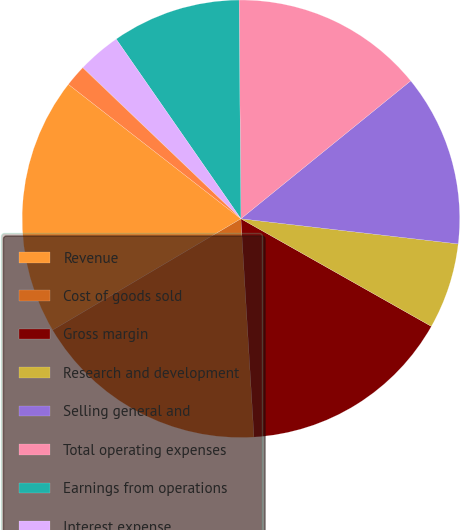Convert chart to OTSL. <chart><loc_0><loc_0><loc_500><loc_500><pie_chart><fcel>Revenue<fcel>Cost of goods sold<fcel>Gross margin<fcel>Research and development<fcel>Selling general and<fcel>Total operating expenses<fcel>Earnings from operations<fcel>Interest expense<fcel>Interest income<fcel>Other (income) expense net<nl><fcel>19.03%<fcel>17.45%<fcel>15.86%<fcel>6.35%<fcel>12.69%<fcel>14.28%<fcel>9.52%<fcel>3.19%<fcel>0.02%<fcel>1.6%<nl></chart> 